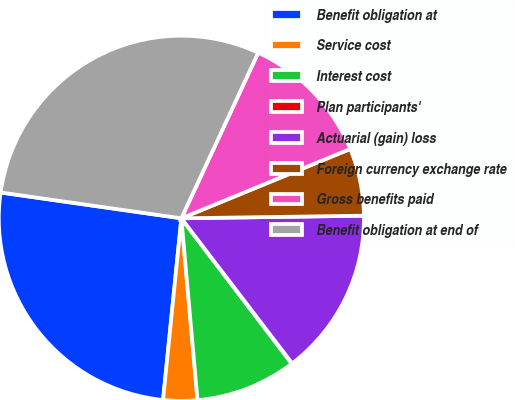Convert chart to OTSL. <chart><loc_0><loc_0><loc_500><loc_500><pie_chart><fcel>Benefit obligation at<fcel>Service cost<fcel>Interest cost<fcel>Plan participants'<fcel>Actuarial (gain) loss<fcel>Foreign currency exchange rate<fcel>Gross benefits paid<fcel>Benefit obligation at end of<nl><fcel>25.66%<fcel>3.01%<fcel>8.93%<fcel>0.04%<fcel>14.85%<fcel>5.97%<fcel>11.89%<fcel>29.66%<nl></chart> 